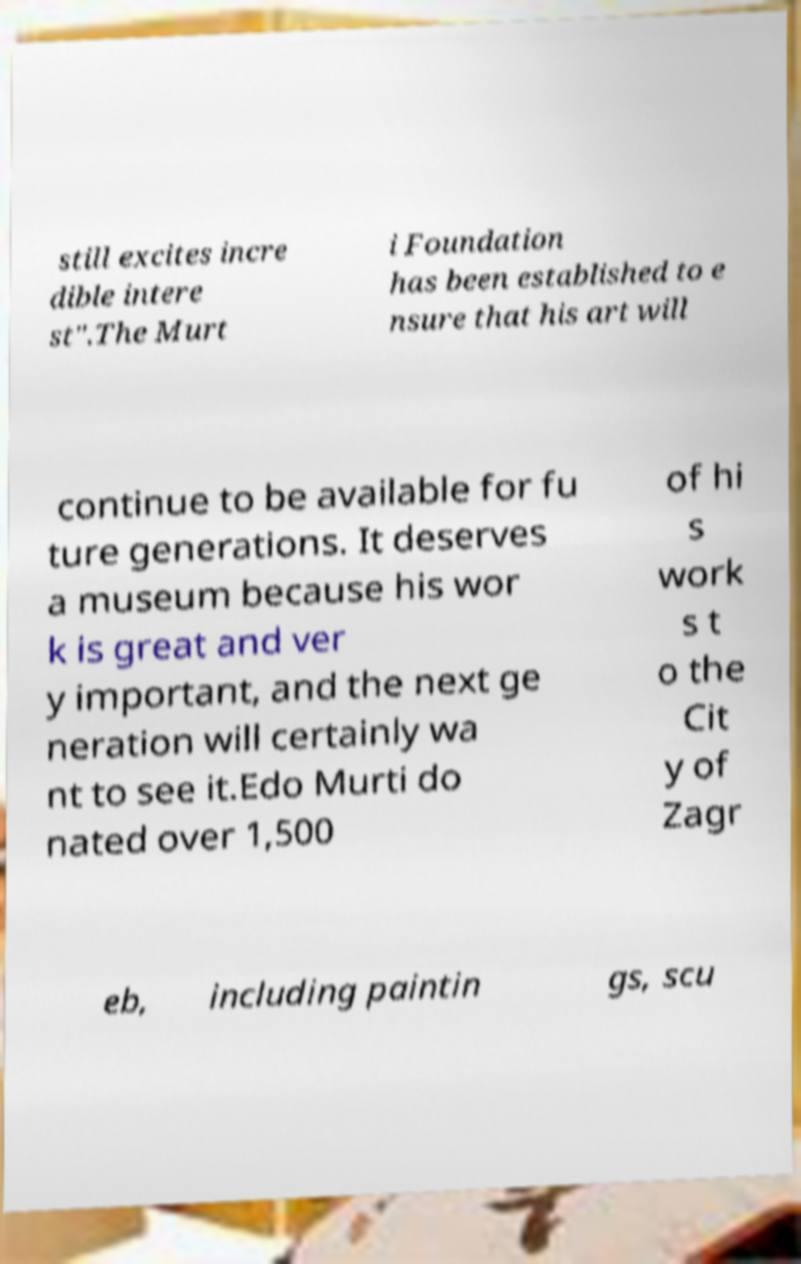Please read and relay the text visible in this image. What does it say? still excites incre dible intere st".The Murt i Foundation has been established to e nsure that his art will continue to be available for fu ture generations. It deserves a museum because his wor k is great and ver y important, and the next ge neration will certainly wa nt to see it.Edo Murti do nated over 1,500 of hi s work s t o the Cit y of Zagr eb, including paintin gs, scu 